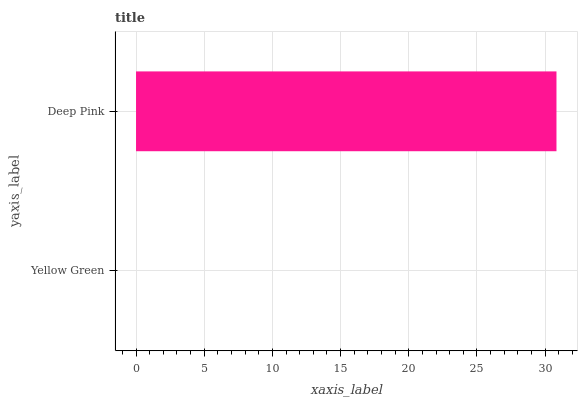Is Yellow Green the minimum?
Answer yes or no. Yes. Is Deep Pink the maximum?
Answer yes or no. Yes. Is Deep Pink the minimum?
Answer yes or no. No. Is Deep Pink greater than Yellow Green?
Answer yes or no. Yes. Is Yellow Green less than Deep Pink?
Answer yes or no. Yes. Is Yellow Green greater than Deep Pink?
Answer yes or no. No. Is Deep Pink less than Yellow Green?
Answer yes or no. No. Is Deep Pink the high median?
Answer yes or no. Yes. Is Yellow Green the low median?
Answer yes or no. Yes. Is Yellow Green the high median?
Answer yes or no. No. Is Deep Pink the low median?
Answer yes or no. No. 